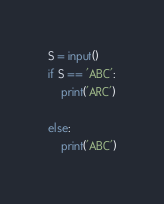Convert code to text. <code><loc_0><loc_0><loc_500><loc_500><_Python_>S = input()
if S == 'ABC':
    print('ARC')

else:
    print('ABC')
</code> 